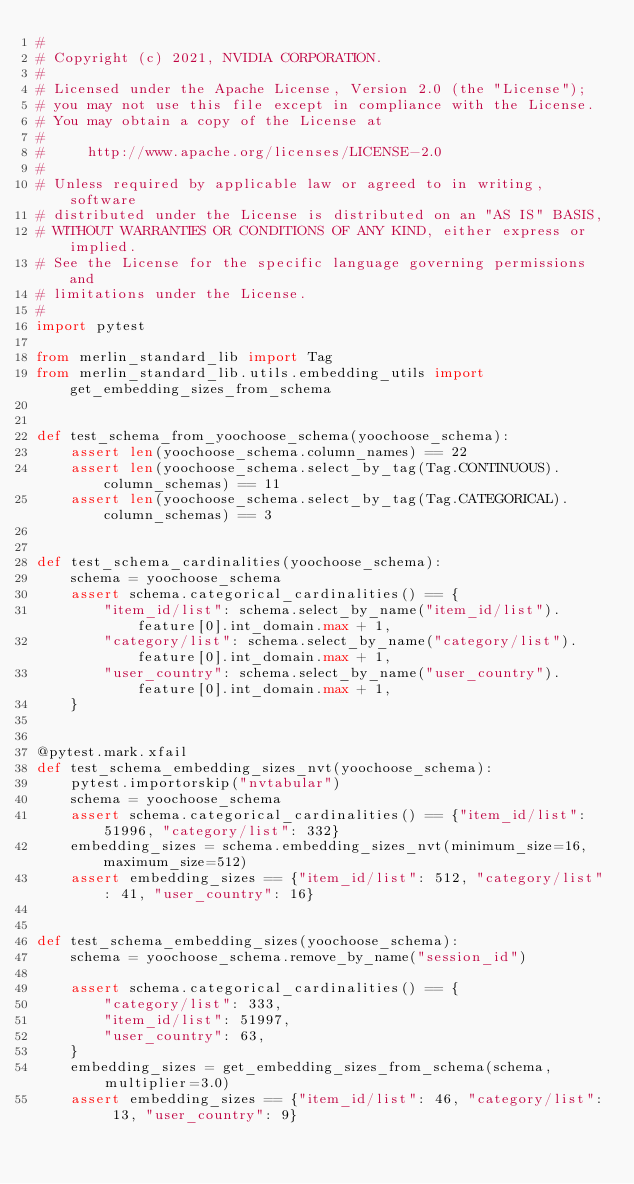<code> <loc_0><loc_0><loc_500><loc_500><_Python_>#
# Copyright (c) 2021, NVIDIA CORPORATION.
#
# Licensed under the Apache License, Version 2.0 (the "License");
# you may not use this file except in compliance with the License.
# You may obtain a copy of the License at
#
#     http://www.apache.org/licenses/LICENSE-2.0
#
# Unless required by applicable law or agreed to in writing, software
# distributed under the License is distributed on an "AS IS" BASIS,
# WITHOUT WARRANTIES OR CONDITIONS OF ANY KIND, either express or implied.
# See the License for the specific language governing permissions and
# limitations under the License.
#
import pytest

from merlin_standard_lib import Tag
from merlin_standard_lib.utils.embedding_utils import get_embedding_sizes_from_schema


def test_schema_from_yoochoose_schema(yoochoose_schema):
    assert len(yoochoose_schema.column_names) == 22
    assert len(yoochoose_schema.select_by_tag(Tag.CONTINUOUS).column_schemas) == 11
    assert len(yoochoose_schema.select_by_tag(Tag.CATEGORICAL).column_schemas) == 3


def test_schema_cardinalities(yoochoose_schema):
    schema = yoochoose_schema
    assert schema.categorical_cardinalities() == {
        "item_id/list": schema.select_by_name("item_id/list").feature[0].int_domain.max + 1,
        "category/list": schema.select_by_name("category/list").feature[0].int_domain.max + 1,
        "user_country": schema.select_by_name("user_country").feature[0].int_domain.max + 1,
    }


@pytest.mark.xfail
def test_schema_embedding_sizes_nvt(yoochoose_schema):
    pytest.importorskip("nvtabular")
    schema = yoochoose_schema
    assert schema.categorical_cardinalities() == {"item_id/list": 51996, "category/list": 332}
    embedding_sizes = schema.embedding_sizes_nvt(minimum_size=16, maximum_size=512)
    assert embedding_sizes == {"item_id/list": 512, "category/list": 41, "user_country": 16}


def test_schema_embedding_sizes(yoochoose_schema):
    schema = yoochoose_schema.remove_by_name("session_id")

    assert schema.categorical_cardinalities() == {
        "category/list": 333,
        "item_id/list": 51997,
        "user_country": 63,
    }
    embedding_sizes = get_embedding_sizes_from_schema(schema, multiplier=3.0)
    assert embedding_sizes == {"item_id/list": 46, "category/list": 13, "user_country": 9}
</code> 